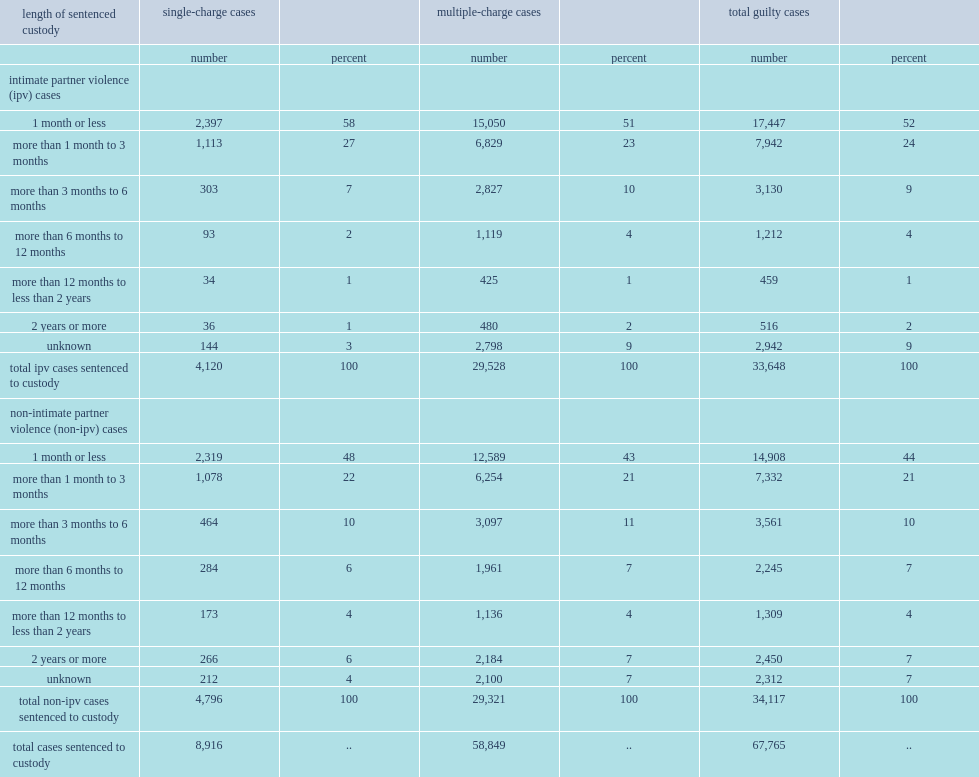What percent of custodial sentences imposed were for one month or less for non-ipv cases? 44.0. How many percent of the non-ipv cases was for more than one year? 11. Among completed ipv cases involving custody, which length of the sentence was more likely to be facing one charge? 1 month or less. In ipv cases, what is the majority length of sentenced custody being received by multiple-charges cases offenders? 1 month or less. What percent of ipv cases found guilty, in cases with multiple charges, were sentenced to more than six months in custody. 7. What percent of ipv cases found guilty of one charge were sentenced to more than six months in custody. 4. 